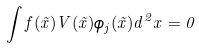Convert formula to latex. <formula><loc_0><loc_0><loc_500><loc_500>\int f ( \vec { x } ) V ( \vec { x } ) \phi _ { j } ( \vec { x } ) d ^ { 2 } x = 0</formula> 